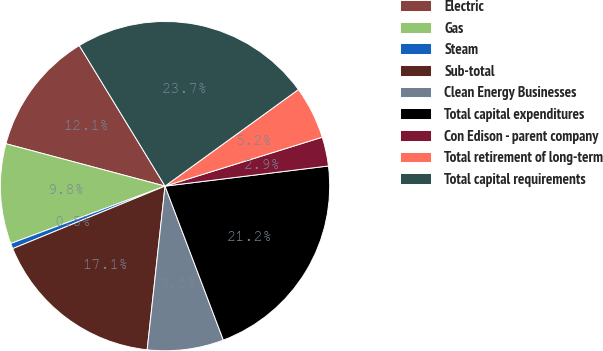Convert chart to OTSL. <chart><loc_0><loc_0><loc_500><loc_500><pie_chart><fcel>Electric<fcel>Gas<fcel>Steam<fcel>Sub-total<fcel>Clean Energy Businesses<fcel>Total capital expenditures<fcel>Con Edison - parent company<fcel>Total retirement of long-term<fcel>Total capital requirements<nl><fcel>12.14%<fcel>9.81%<fcel>0.53%<fcel>17.07%<fcel>7.49%<fcel>21.19%<fcel>2.85%<fcel>5.17%<fcel>23.74%<nl></chart> 